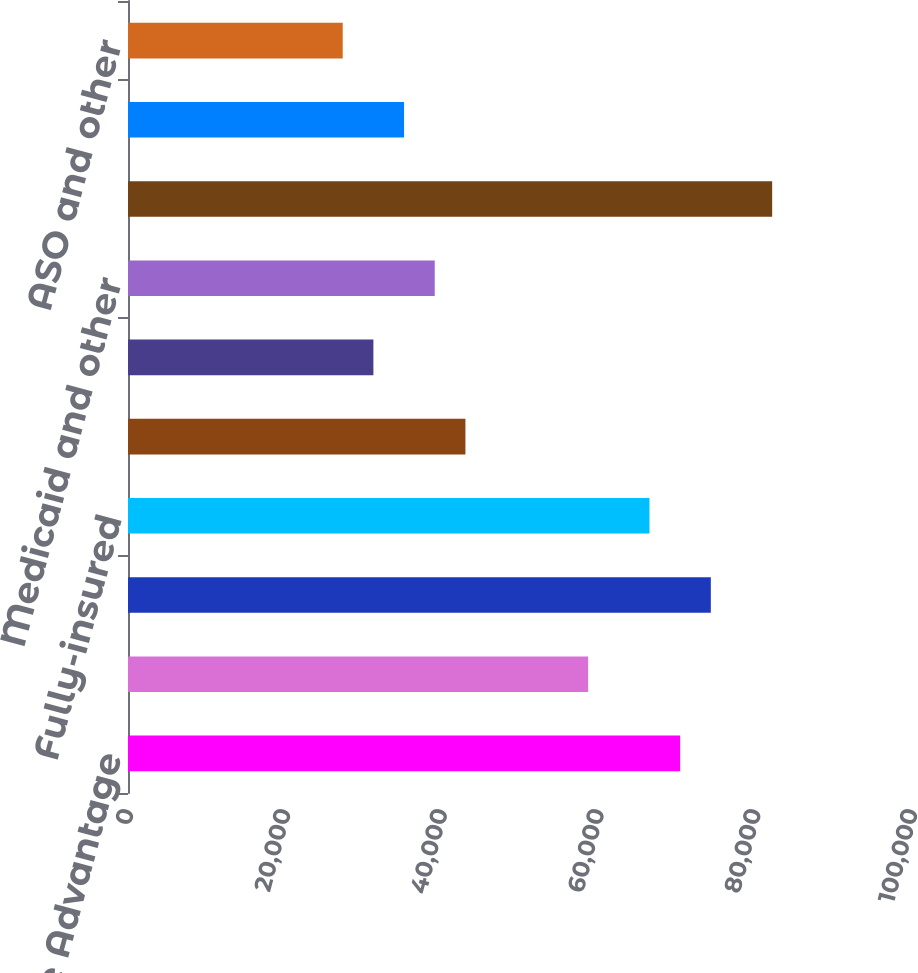Convert chart. <chart><loc_0><loc_0><loc_500><loc_500><bar_chart><fcel>Medicare Advantage<fcel>Medicare stand-alone PDP<fcel>Total Medicare<fcel>Fully-insured<fcel>Specialty<fcel>Military services<fcel>Medicaid and other<fcel>Total premiums<fcel>Provider<fcel>ASO and other<nl><fcel>70426.3<fcel>58688.7<fcel>74338.8<fcel>66513.7<fcel>43038.5<fcel>31300.9<fcel>39126<fcel>82163.9<fcel>35213.4<fcel>27388.3<nl></chart> 